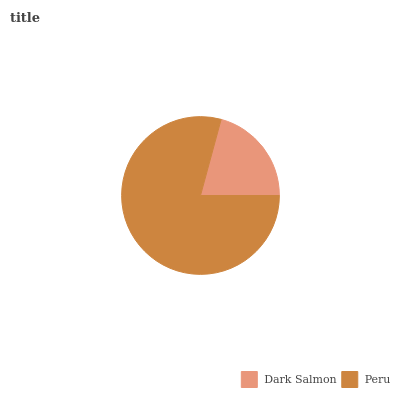Is Dark Salmon the minimum?
Answer yes or no. Yes. Is Peru the maximum?
Answer yes or no. Yes. Is Peru the minimum?
Answer yes or no. No. Is Peru greater than Dark Salmon?
Answer yes or no. Yes. Is Dark Salmon less than Peru?
Answer yes or no. Yes. Is Dark Salmon greater than Peru?
Answer yes or no. No. Is Peru less than Dark Salmon?
Answer yes or no. No. Is Peru the high median?
Answer yes or no. Yes. Is Dark Salmon the low median?
Answer yes or no. Yes. Is Dark Salmon the high median?
Answer yes or no. No. Is Peru the low median?
Answer yes or no. No. 